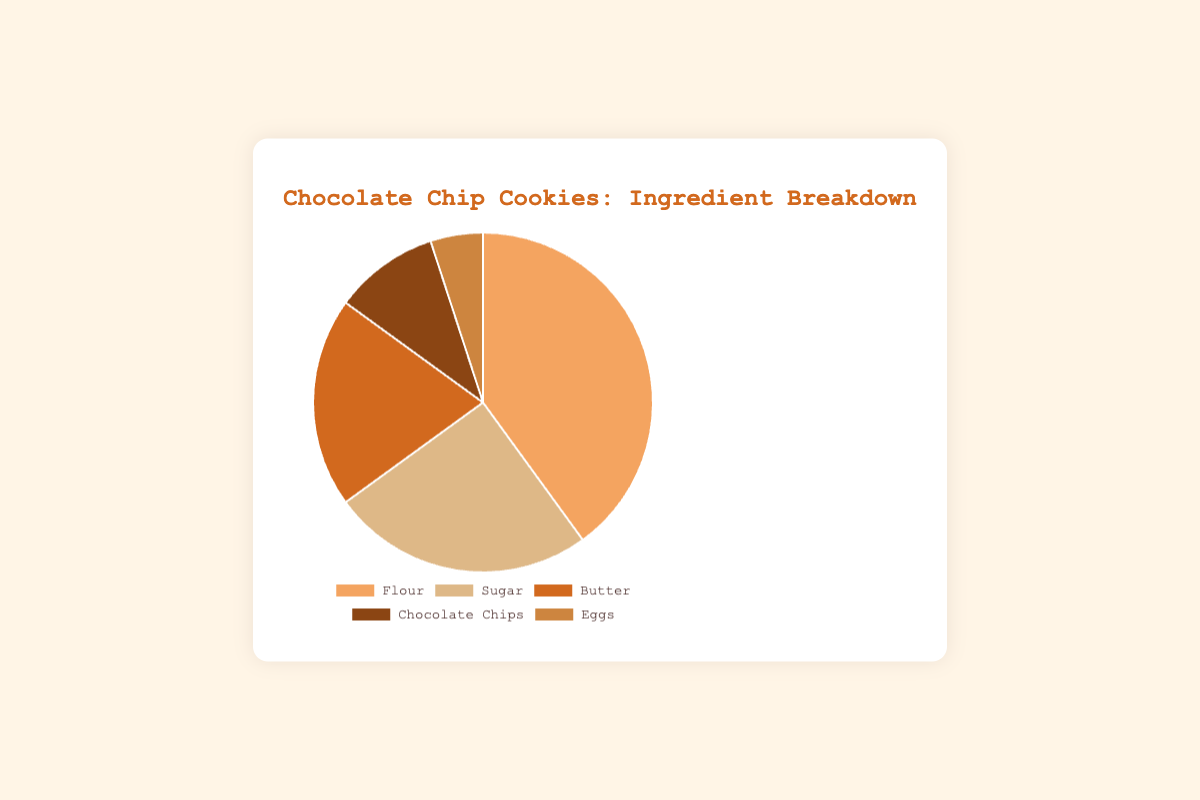What's the most abundant ingredient in the Chocolate Chip Cookies? By looking at the pie chart, the largest section represents the most abundant ingredient. The section labeled 'Flour' is the largest.
Answer: Flour What's the total percentage of Flour and Sugar in the Chocolate Chip Cookies? To find the total percentage of Flour and Sugar, add the individual percentages of these ingredients. Flour is 40% and Sugar is 25%. 40 + 25 = 65.
Answer: 65% Which ingredient in the Chocolate Chip Cookies is used the least? The pie chart shows the smallest section representing the least used ingredient. The section labeled 'Eggs' is the smallest.
Answer: Eggs How much more Flour is used than Chocolate Chips in the Chocolate Chip Cookies? To find the difference, subtract the percentage of Chocolate Chips from the percentage of Flour. Flour is 40% and Chocolate Chips are 10%. 40 - 10 = 30.
Answer: 30% Which colors represent the majority and minority ingredients in the Chocolate Chip Cookies? The majority ingredient 'Flour' is represented by a certain color, and the minority ingredient 'Eggs' is represented by a certain color. The color of the largest section (Flour) is light brown (Flour), and the color of the smallest section (Eggs) is buff (Eggs).
Answer: Flour: light brown, Eggs: buff What is the combined percentage of Butter and Chocolate Chips in the Chocolate Chip Cookies? To find the combined percentage, add the individual percentages of Butter and Chocolate Chips. Butter is 20% and Chocolate Chips are 10%. 20 + 10 = 30.
Answer: 30% How does the percentage of Eggs compare to the percentage of Butter in the Chocolate Chip Cookies? Compare the percentage values of Eggs and Butter directly from the pie chart. Eggs are 5% and Butter is 20%. 5% is less than 20%.
Answer: Eggs are less If Eggs and Chocolate Chips are combined, will their total percentage exceed Sugar in the Chocolate Chip Cookies? Add the percentages of Eggs and Chocolate Chips and compare to the percentage of Sugar. Eggs are 5% and Chocolate Chips are 10%, so the combined percentage is 5 + 10 = 15%. Sugar is 25%. 15 < 25.
Answer: No Which ingredients together make up more than half of the Chocolate Chip Cookies? Sum the percentages of each ingredient and find which combinations exceed 50%. Flour (40%) and Sugar (25%) combined are 40 + 25 = 65%, which is more than 50%.
Answer: Flour and Sugar 